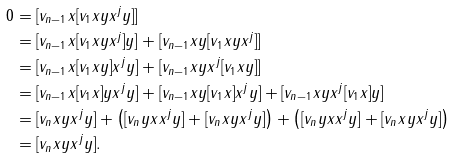<formula> <loc_0><loc_0><loc_500><loc_500>0 & = [ v _ { n - 1 } x [ v _ { 1 } x y x ^ { j } y ] ] \\ & = [ v _ { n - 1 } x [ v _ { 1 } x y x ^ { j } ] y ] + [ v _ { n - 1 } x y [ v _ { 1 } x y x ^ { j } ] ] \\ & = [ v _ { n - 1 } x [ v _ { 1 } x y ] x ^ { j } y ] + [ v _ { n - 1 } x y x ^ { j } [ v _ { 1 } x y ] ] \\ & = [ v _ { n - 1 } x [ v _ { 1 } x ] y x ^ { j } y ] + [ v _ { n - 1 } x y [ v _ { 1 } x ] x ^ { j } y ] + [ v _ { n - 1 } x y x ^ { j } [ v _ { 1 } x ] y ] \\ & = [ v _ { n } x y x ^ { j } y ] + \left ( [ v _ { n } y x x ^ { j } y ] + [ v _ { n } x y x ^ { j } y ] \right ) + \left ( [ v _ { n } y x x ^ { j } y ] + [ v _ { n } x y x ^ { j } y ] \right ) \\ & = [ v _ { n } x y x ^ { j } y ] .</formula> 